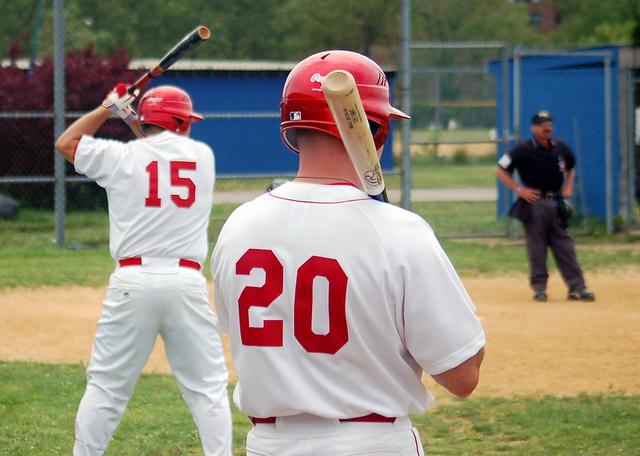What color are the numbers written on the jerseys of the players?
Write a very short answer. Red. What do the numbers on the player's jerseys mean?
Short answer required. Player number. Is there anything there to drink?
Answer briefly. No. How many players are there?
Short answer required. 2. 